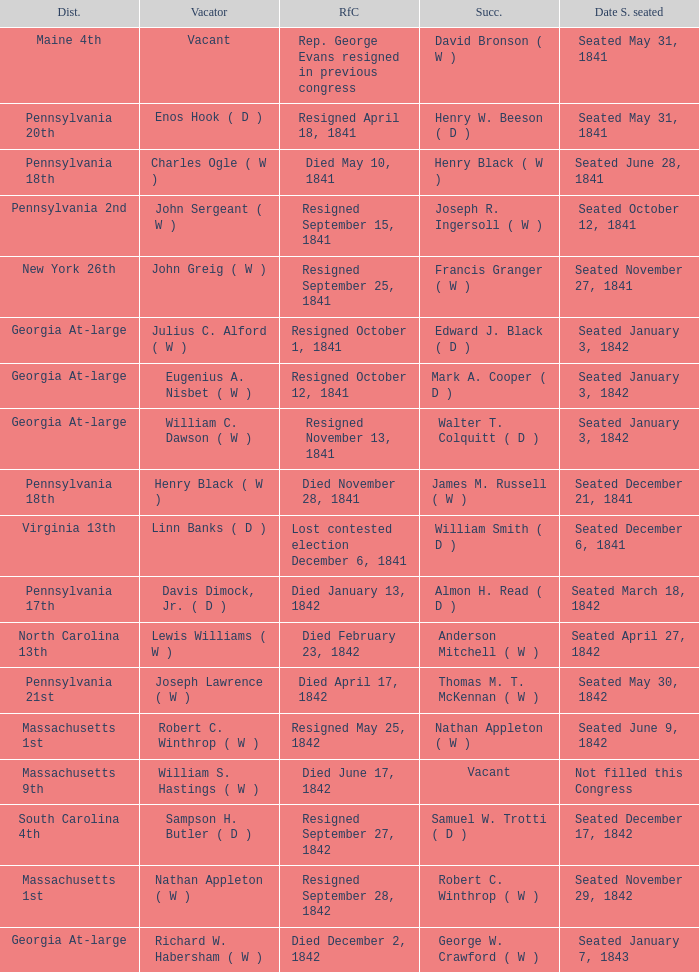Name the date successor seated for pennsylvania 17th Seated March 18, 1842. 